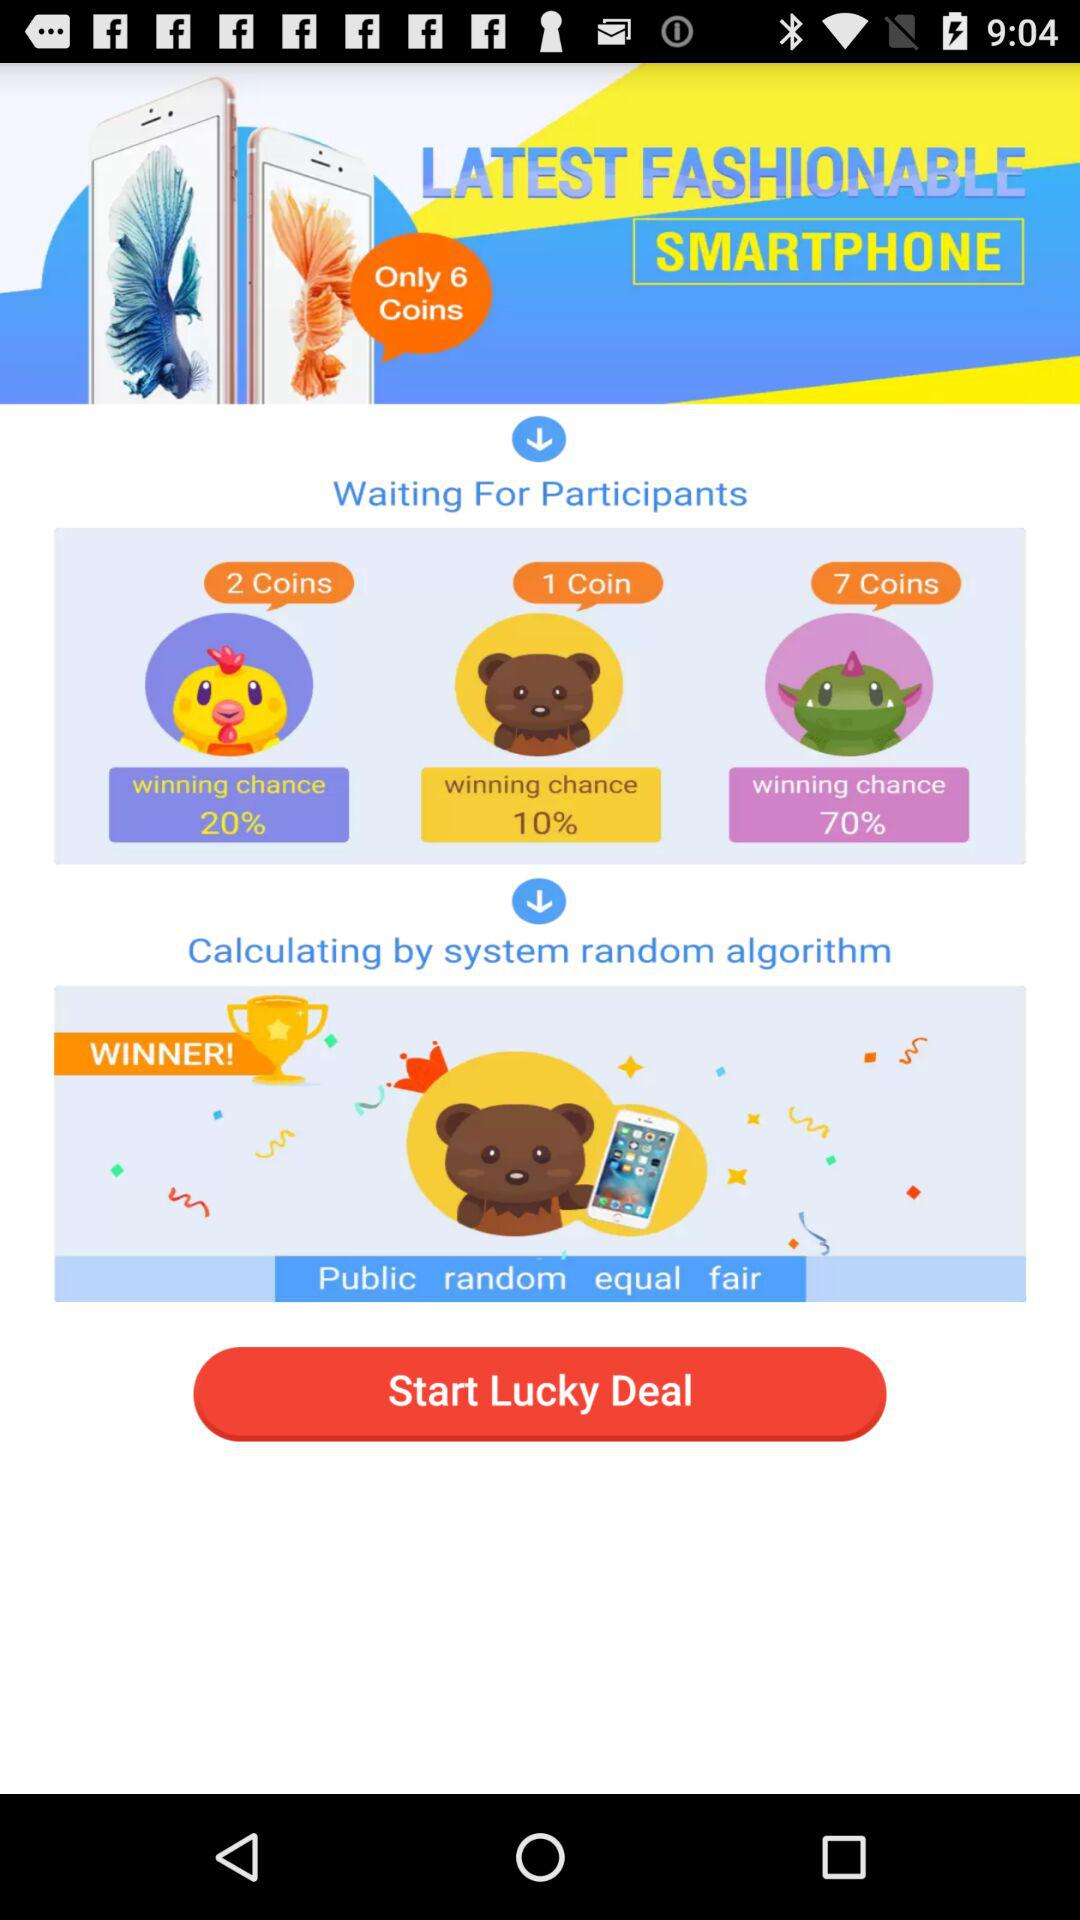What is the winning chance of blue emojis?
When the provided information is insufficient, respond with <no answer>. <no answer> 